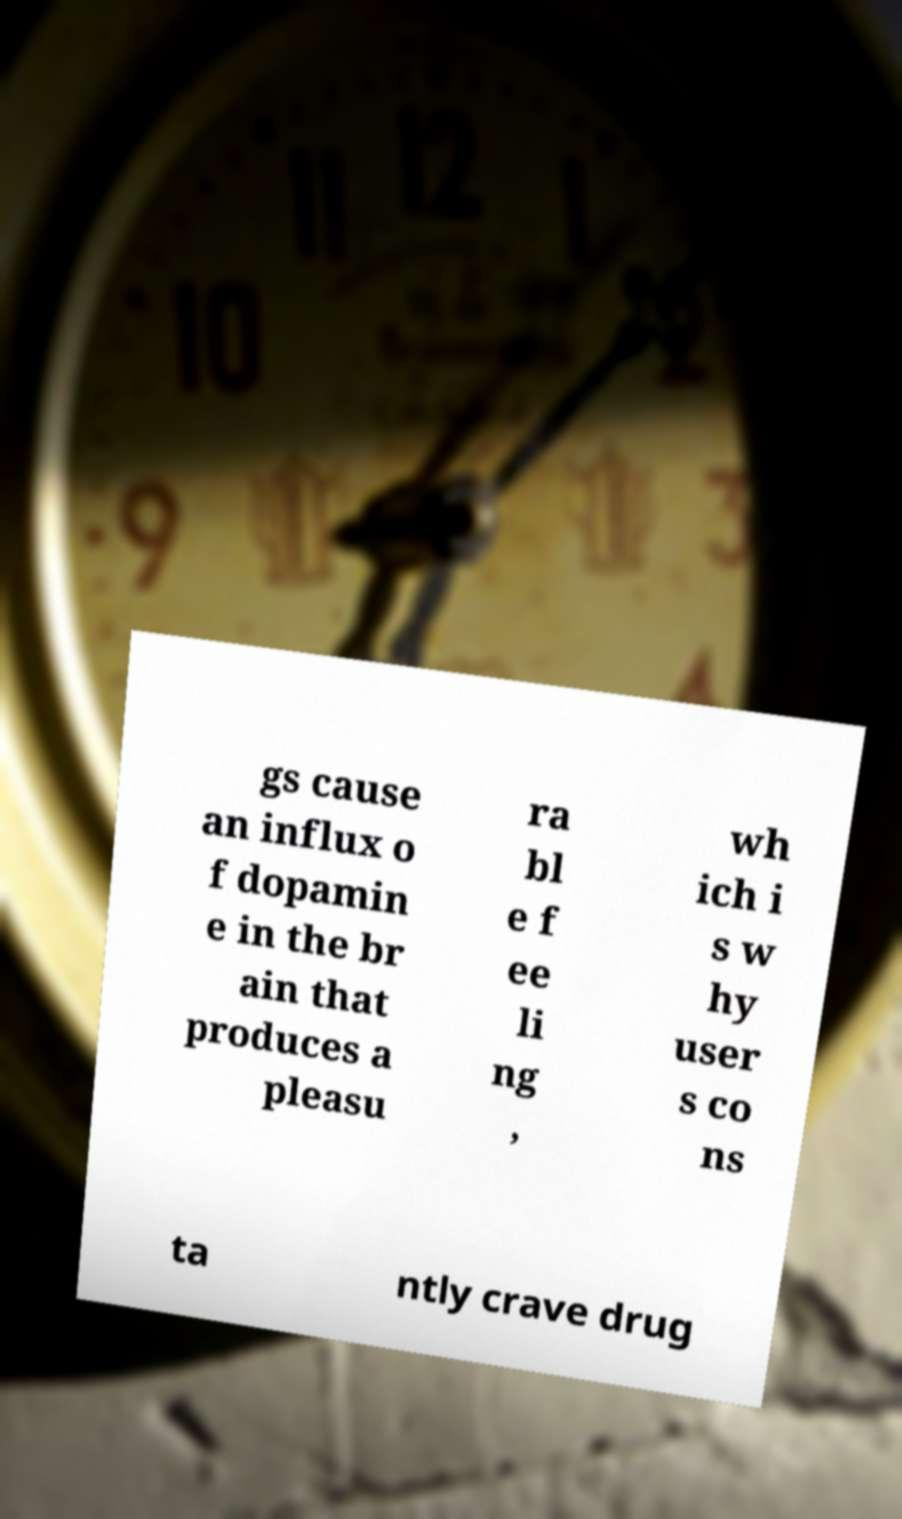What messages or text are displayed in this image? I need them in a readable, typed format. gs cause an influx o f dopamin e in the br ain that produces a pleasu ra bl e f ee li ng , wh ich i s w hy user s co ns ta ntly crave drug 